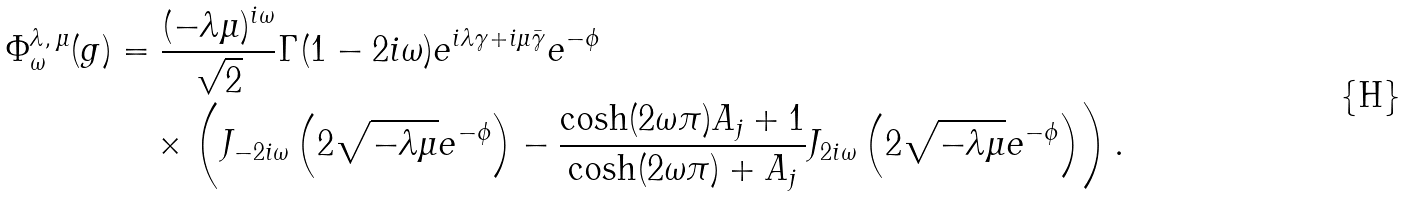Convert formula to latex. <formula><loc_0><loc_0><loc_500><loc_500>\Phi ^ { \lambda , \, \mu } _ { \omega } ( g ) & = \frac { ( - \lambda \mu ) ^ { i \omega } } { \sqrt { 2 } } \Gamma ( 1 - 2 i \omega ) e ^ { i \lambda \gamma + i \mu \bar { \gamma } } e ^ { - \phi } \\ & \quad \times \left ( J _ { - 2 i \omega } \left ( 2 \sqrt { - \lambda \mu } e ^ { - \phi } \right ) - \frac { \cosh ( 2 \omega \pi ) A _ { j } + 1 } { \cosh ( 2 \omega \pi ) + A _ { j } } J _ { 2 i \omega } \left ( 2 \sqrt { - \lambda \mu } e ^ { - \phi } \right ) \right ) .</formula> 